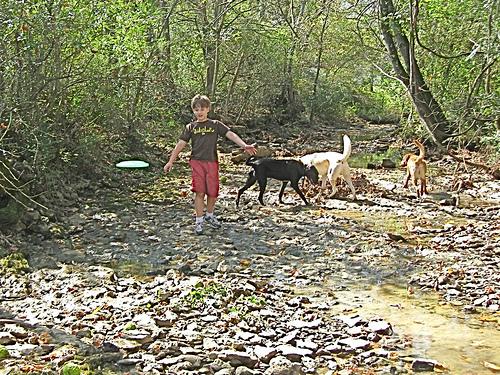How many animals in picture?
Write a very short answer. 3. What is flying through the air?
Quick response, please. Frisbee. What color is the boy's shorts?
Concise answer only. Red. 